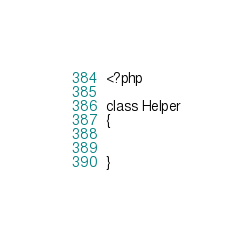Convert code to text. <code><loc_0><loc_0><loc_500><loc_500><_PHP_><?php

class Helper
{


}</code> 